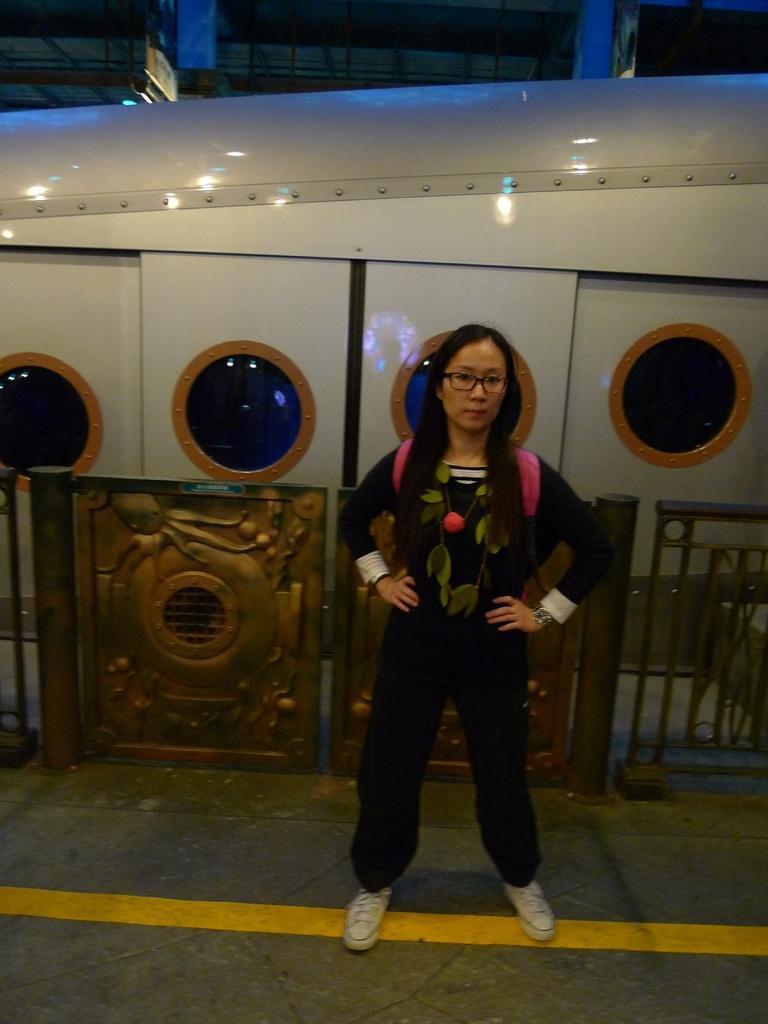In one or two sentences, can you explain what this image depicts? In this image we can see a lady wearing specs, bag, watch is standing. In the back there is a railing with doors. Also there is a train. In the background there are railings. 